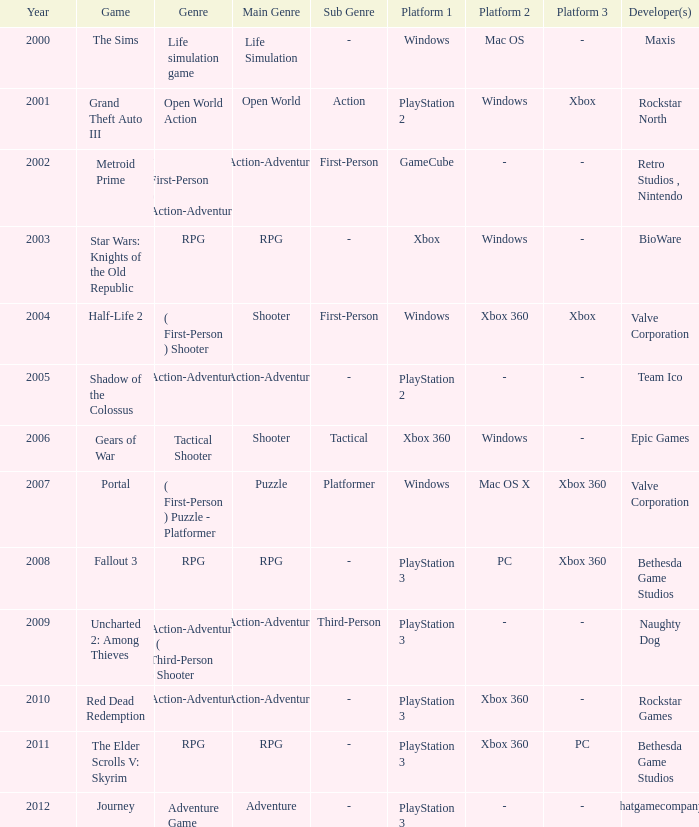What game was in 2001? Grand Theft Auto III. 